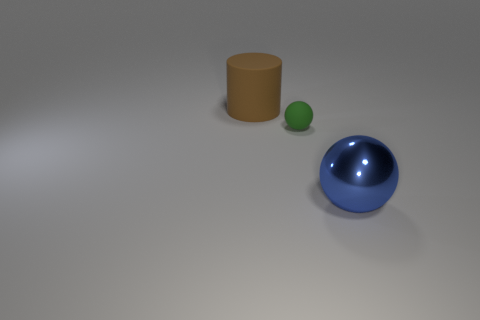What number of metal objects have the same shape as the tiny matte object?
Offer a terse response. 1. There is a blue object that is the same size as the brown rubber thing; what is it made of?
Provide a short and direct response. Metal. Is there a brown rubber cylinder that has the same size as the blue metallic object?
Give a very brief answer. Yes. Are there fewer large cylinders on the right side of the brown cylinder than tiny red matte things?
Provide a succinct answer. No. Is the number of green spheres that are in front of the small ball less than the number of big cylinders that are left of the big sphere?
Ensure brevity in your answer.  Yes. How many cylinders are either big red objects or blue shiny objects?
Your response must be concise. 0. Are the large thing in front of the big brown matte thing and the big thing behind the blue metal object made of the same material?
Your answer should be compact. No. What is the shape of the other thing that is the same size as the shiny object?
Offer a terse response. Cylinder. How many other things are there of the same color as the metal thing?
Make the answer very short. 0. What number of brown objects are either big metallic spheres or big rubber things?
Ensure brevity in your answer.  1. 